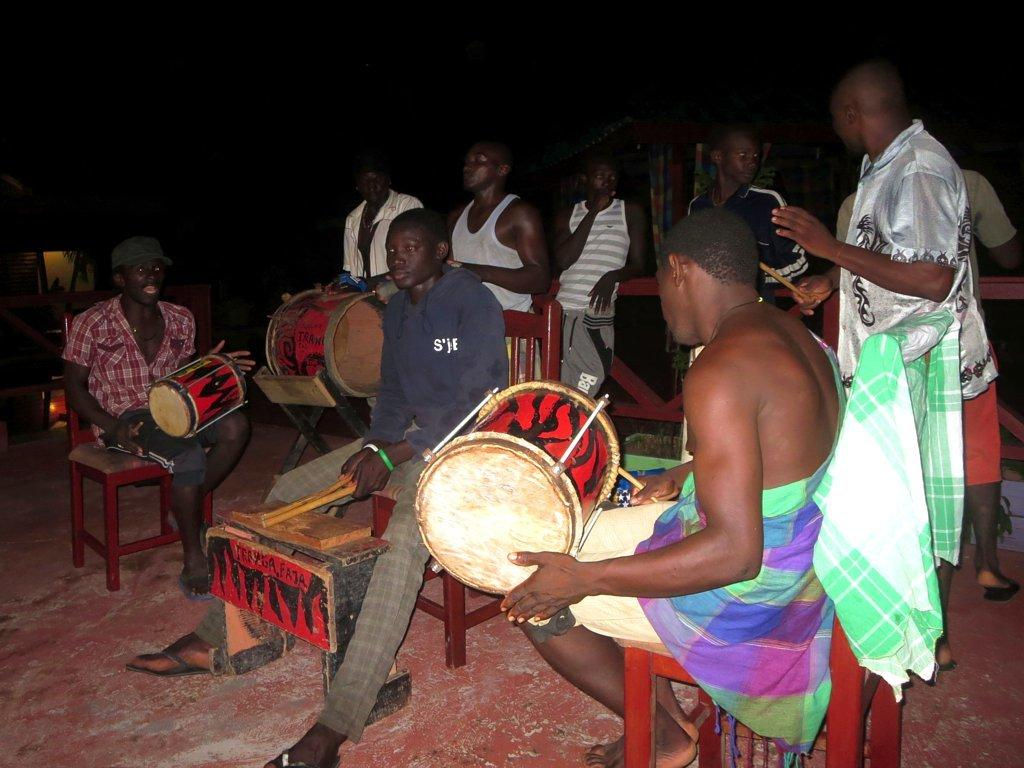What are the people in the image doing? The people are sitting on chairs and playing musical instruments. Can you describe the position of the people in the image? The people are sitting on chairs, and there is a person standing on the right side of the image. How does the water flow in the image? There is no water present in the image, so it cannot flow. What type of jump can be seen in the image? There is no jumping activity depicted in the image. 